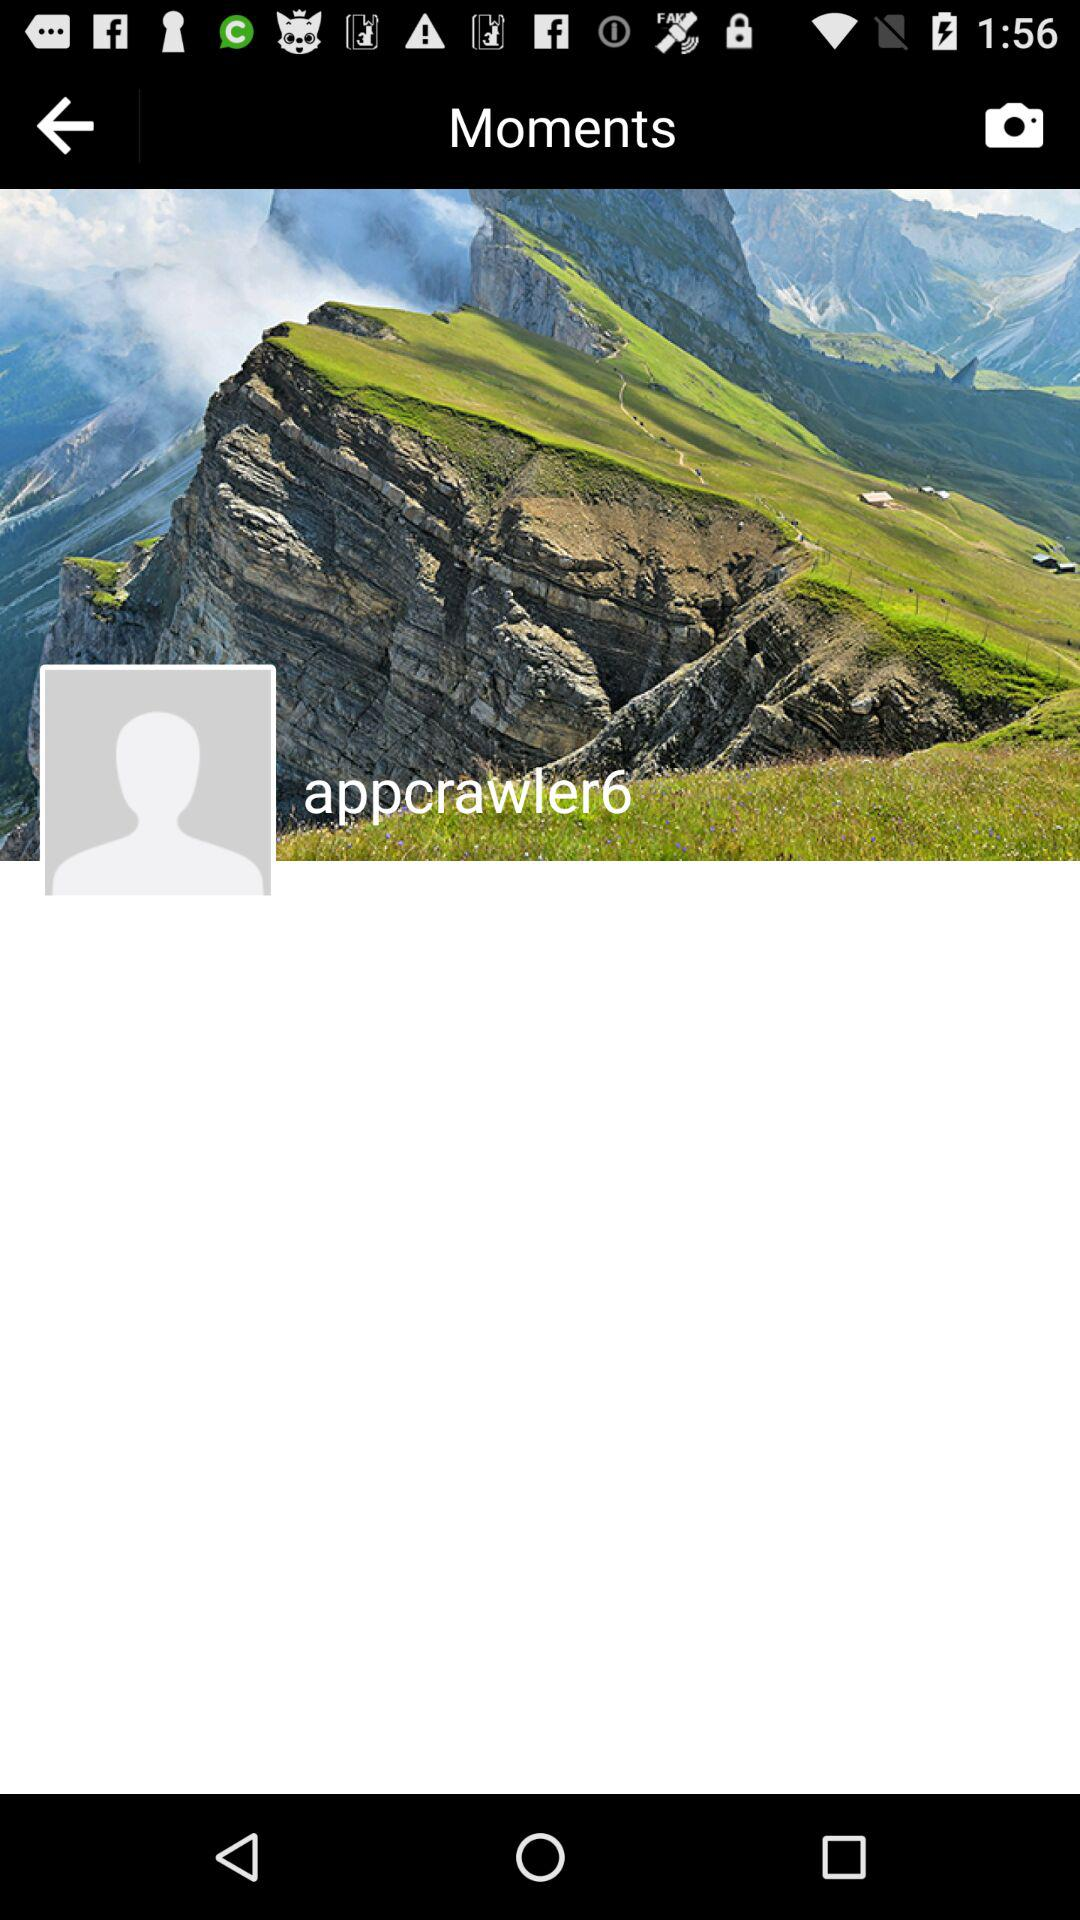What is the name of the folder? The name of the folder is "Moments". 